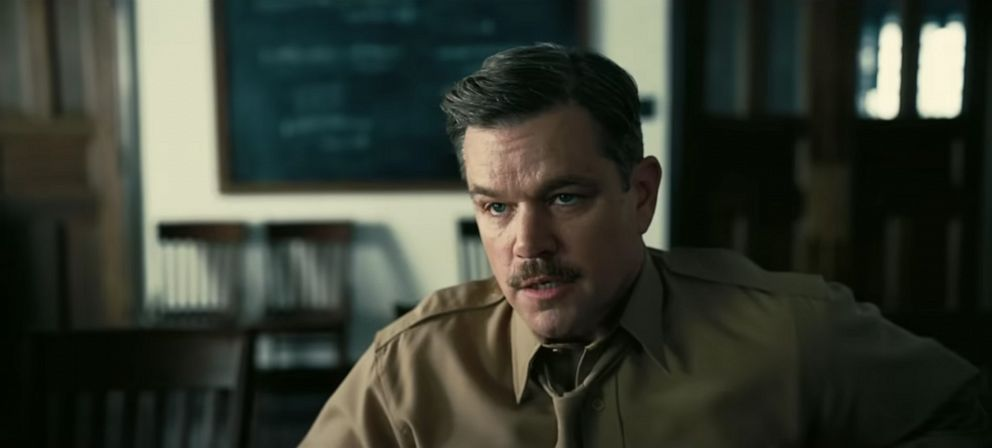 It looks like we are observing an intense moment within an academic environment. Could this be a student consulting a professor about an unsolved equation? The blackboard with equations in the background seems quite significant. What do you think the subject is focused on? Given the serious expression and the blackboard filled with equations, it seems plausible that the subject is deeply engrossed in solving a complex mathematical problem or discussing a theoretical concept. The academic setting and the subject's focused demeanor evoke a sense of intellectual pursuit and curiosity. What might be some possible equations on the blackboard? The blackboard could feature a variety of mathematical or physics equations. It might include advanced calculus, quantum mechanics formulas, or even theoretical physics equations describing particles and forces. Additionally, it could contain a set of unsolved problems or derivations that are central to the discussion happening in the scene. 